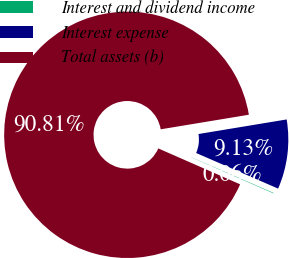Convert chart. <chart><loc_0><loc_0><loc_500><loc_500><pie_chart><fcel>Interest and dividend income<fcel>Interest expense<fcel>Total assets (b)<nl><fcel>0.06%<fcel>9.13%<fcel>90.81%<nl></chart> 